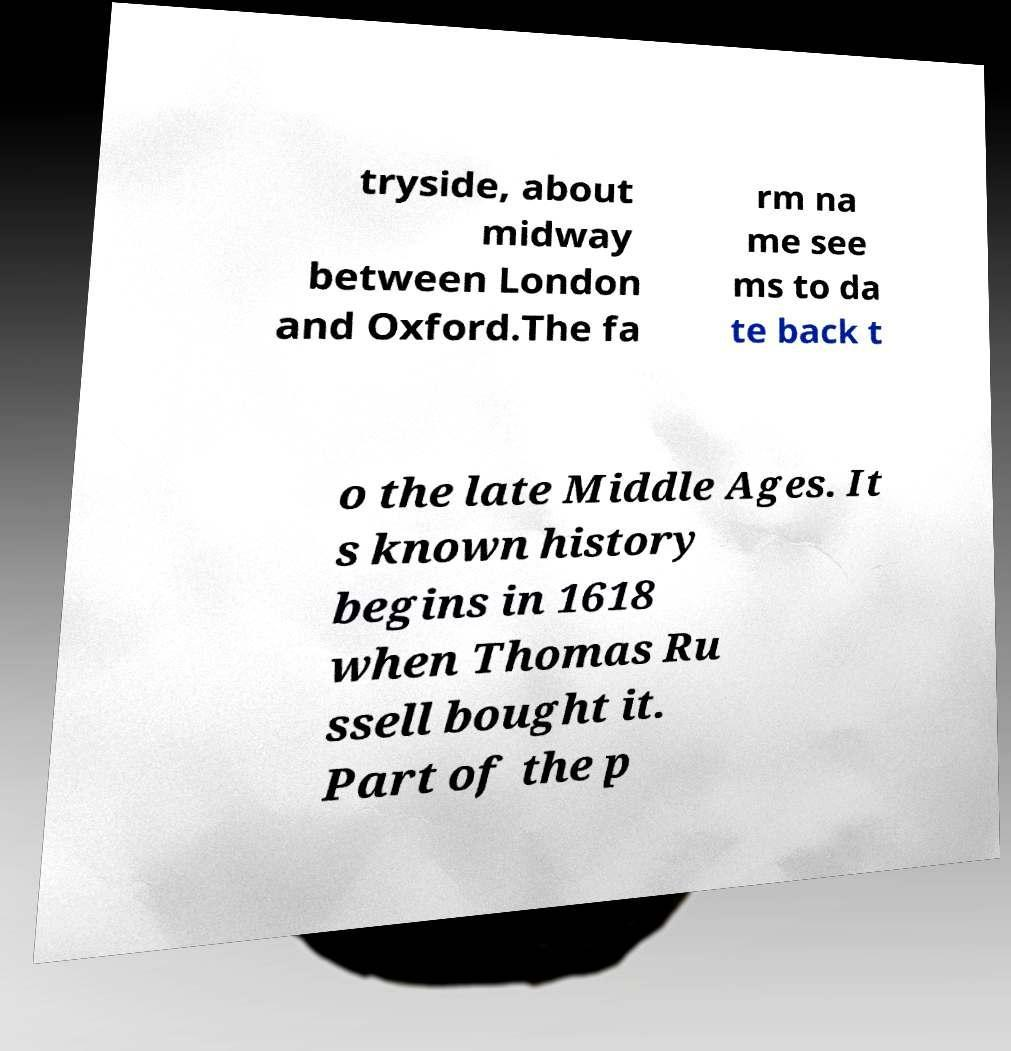There's text embedded in this image that I need extracted. Can you transcribe it verbatim? tryside, about midway between London and Oxford.The fa rm na me see ms to da te back t o the late Middle Ages. It s known history begins in 1618 when Thomas Ru ssell bought it. Part of the p 